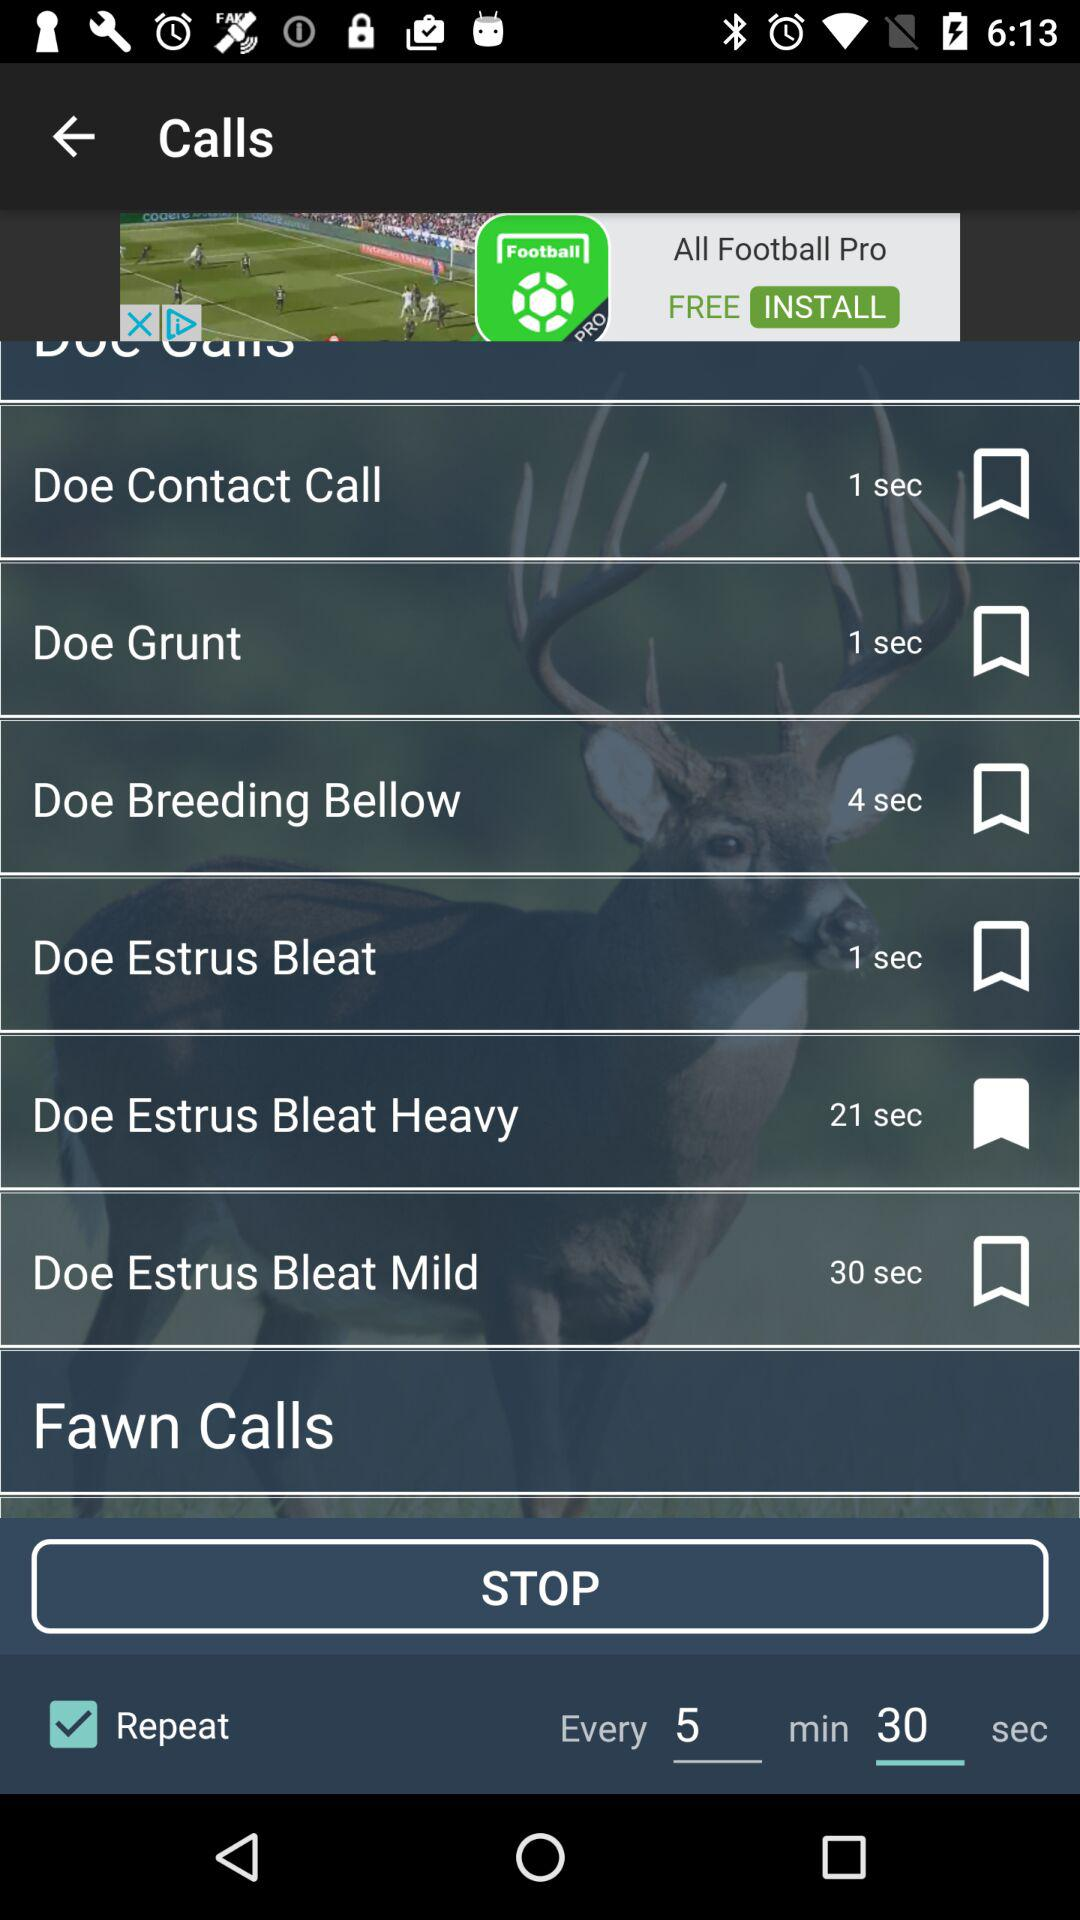What is the time duration?
When the provided information is insufficient, respond with <no answer>. <no answer> 